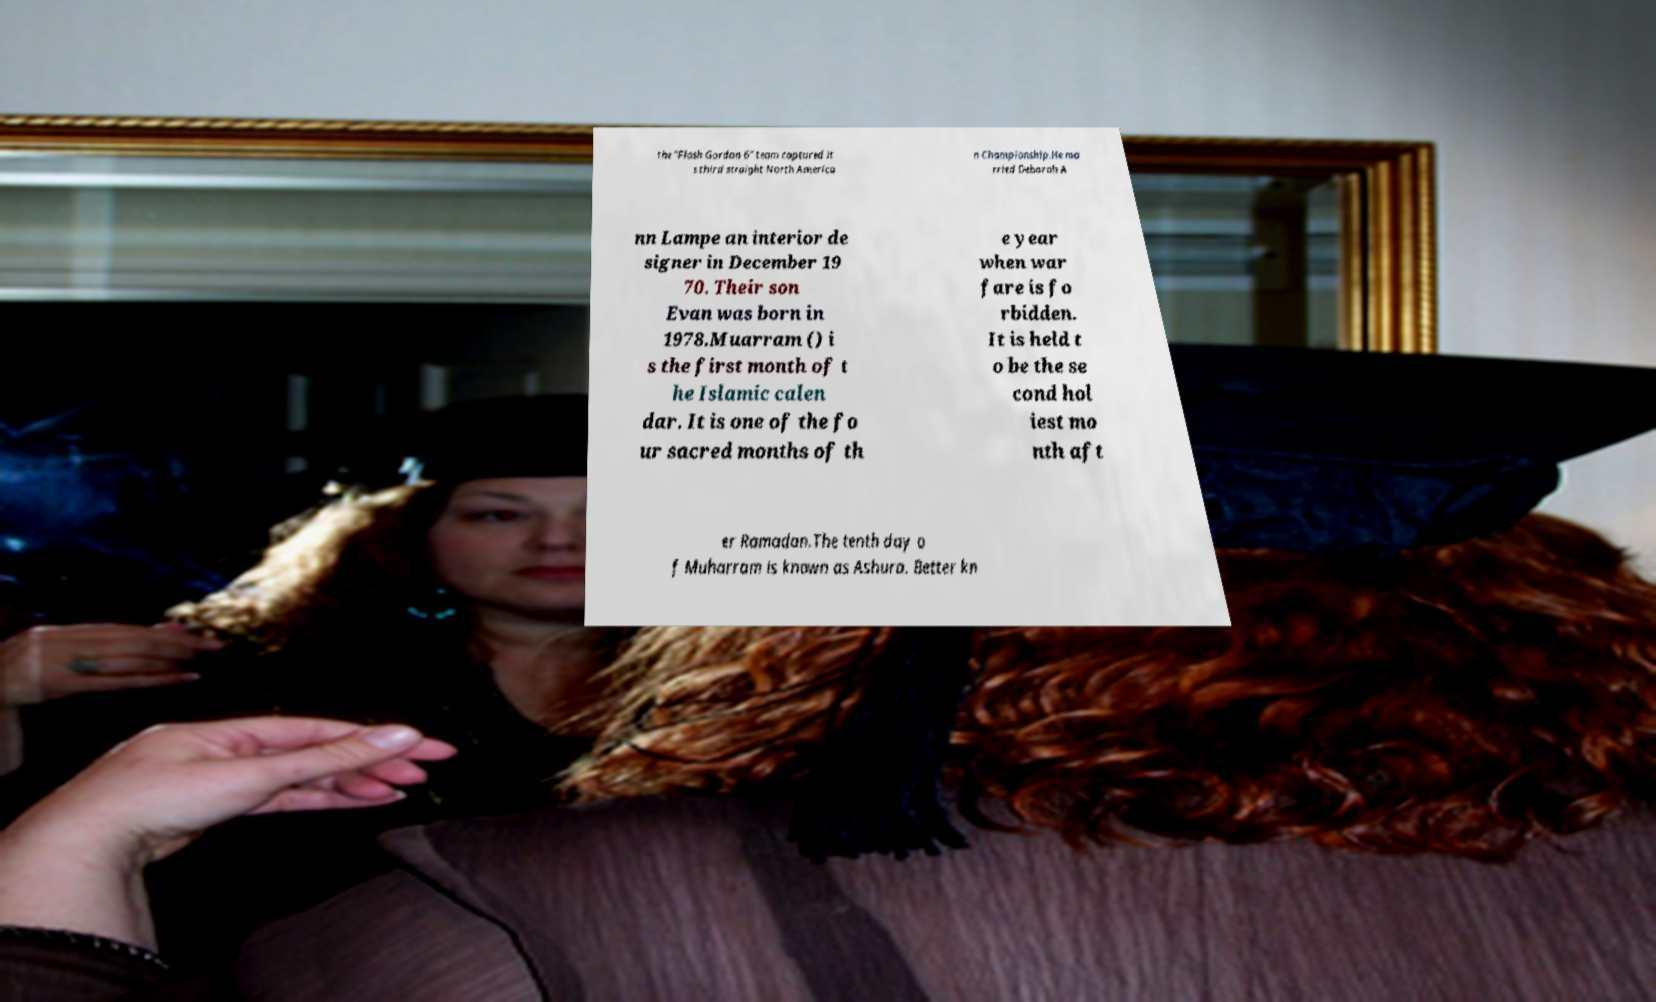What messages or text are displayed in this image? I need them in a readable, typed format. the "Flash Gordon 6" team captured it s third straight North America n Championship.He ma rried Deborah A nn Lampe an interior de signer in December 19 70. Their son Evan was born in 1978.Muarram () i s the first month of t he Islamic calen dar. It is one of the fo ur sacred months of th e year when war fare is fo rbidden. It is held t o be the se cond hol iest mo nth aft er Ramadan.The tenth day o f Muharram is known as Ashura. Better kn 